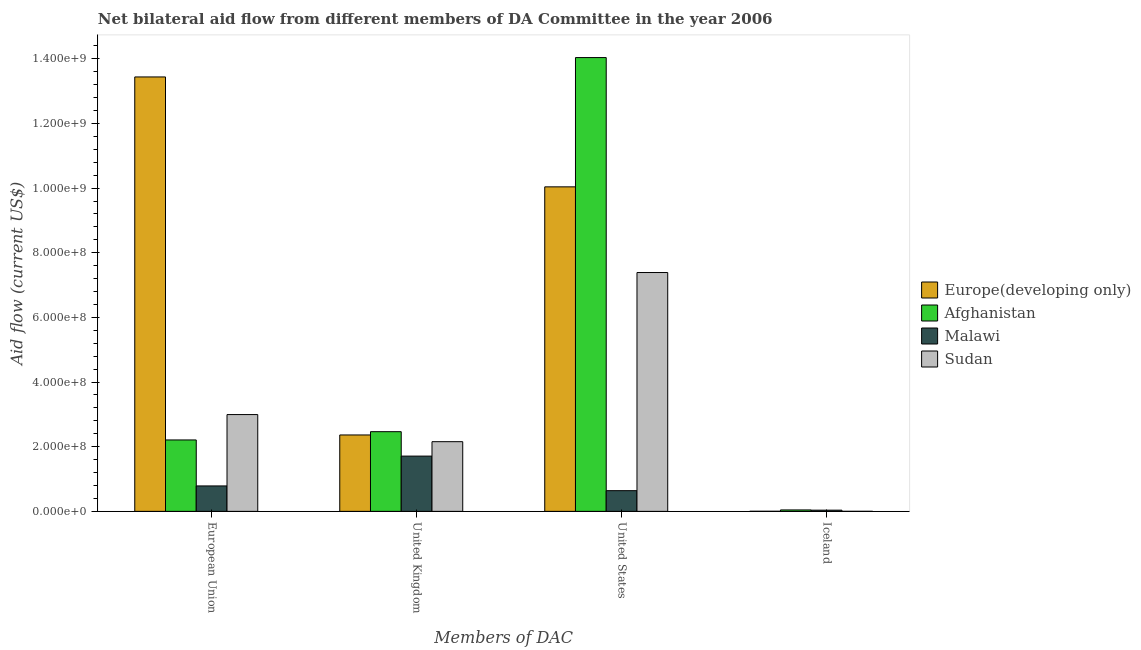Are the number of bars per tick equal to the number of legend labels?
Your response must be concise. Yes. What is the label of the 4th group of bars from the left?
Provide a short and direct response. Iceland. What is the amount of aid given by uk in Afghanistan?
Give a very brief answer. 2.46e+08. Across all countries, what is the maximum amount of aid given by eu?
Ensure brevity in your answer.  1.34e+09. Across all countries, what is the minimum amount of aid given by iceland?
Make the answer very short. 1.40e+05. In which country was the amount of aid given by iceland maximum?
Offer a very short reply. Afghanistan. In which country was the amount of aid given by eu minimum?
Offer a very short reply. Malawi. What is the total amount of aid given by us in the graph?
Keep it short and to the point. 3.21e+09. What is the difference between the amount of aid given by uk in Malawi and that in Afghanistan?
Give a very brief answer. -7.56e+07. What is the difference between the amount of aid given by uk in Afghanistan and the amount of aid given by us in Malawi?
Offer a very short reply. 1.82e+08. What is the average amount of aid given by eu per country?
Make the answer very short. 4.86e+08. What is the difference between the amount of aid given by us and amount of aid given by eu in Sudan?
Offer a very short reply. 4.39e+08. In how many countries, is the amount of aid given by us greater than 1400000000 US$?
Your answer should be compact. 1. What is the ratio of the amount of aid given by eu in Sudan to that in Malawi?
Provide a short and direct response. 3.81. What is the difference between the highest and the second highest amount of aid given by iceland?
Offer a terse response. 6.90e+05. What is the difference between the highest and the lowest amount of aid given by iceland?
Provide a succinct answer. 4.28e+06. In how many countries, is the amount of aid given by uk greater than the average amount of aid given by uk taken over all countries?
Offer a very short reply. 2. What does the 2nd bar from the left in United States represents?
Provide a succinct answer. Afghanistan. What does the 1st bar from the right in United Kingdom represents?
Offer a terse response. Sudan. Is it the case that in every country, the sum of the amount of aid given by eu and amount of aid given by uk is greater than the amount of aid given by us?
Ensure brevity in your answer.  No. How many bars are there?
Keep it short and to the point. 16. Are all the bars in the graph horizontal?
Ensure brevity in your answer.  No. Does the graph contain any zero values?
Your answer should be compact. No. Does the graph contain grids?
Make the answer very short. No. How are the legend labels stacked?
Your answer should be compact. Vertical. What is the title of the graph?
Offer a terse response. Net bilateral aid flow from different members of DA Committee in the year 2006. What is the label or title of the X-axis?
Offer a very short reply. Members of DAC. What is the Aid flow (current US$) in Europe(developing only) in European Union?
Offer a very short reply. 1.34e+09. What is the Aid flow (current US$) of Afghanistan in European Union?
Provide a succinct answer. 2.21e+08. What is the Aid flow (current US$) in Malawi in European Union?
Give a very brief answer. 7.87e+07. What is the Aid flow (current US$) in Sudan in European Union?
Offer a terse response. 2.99e+08. What is the Aid flow (current US$) in Europe(developing only) in United Kingdom?
Provide a short and direct response. 2.36e+08. What is the Aid flow (current US$) of Afghanistan in United Kingdom?
Keep it short and to the point. 2.46e+08. What is the Aid flow (current US$) of Malawi in United Kingdom?
Keep it short and to the point. 1.71e+08. What is the Aid flow (current US$) in Sudan in United Kingdom?
Ensure brevity in your answer.  2.16e+08. What is the Aid flow (current US$) in Europe(developing only) in United States?
Offer a very short reply. 1.00e+09. What is the Aid flow (current US$) in Afghanistan in United States?
Offer a terse response. 1.40e+09. What is the Aid flow (current US$) of Malawi in United States?
Provide a short and direct response. 6.40e+07. What is the Aid flow (current US$) in Sudan in United States?
Provide a short and direct response. 7.39e+08. What is the Aid flow (current US$) in Europe(developing only) in Iceland?
Provide a succinct answer. 2.80e+05. What is the Aid flow (current US$) of Afghanistan in Iceland?
Your response must be concise. 4.42e+06. What is the Aid flow (current US$) in Malawi in Iceland?
Offer a very short reply. 3.73e+06. What is the Aid flow (current US$) of Sudan in Iceland?
Your answer should be compact. 1.40e+05. Across all Members of DAC, what is the maximum Aid flow (current US$) in Europe(developing only)?
Your answer should be compact. 1.34e+09. Across all Members of DAC, what is the maximum Aid flow (current US$) in Afghanistan?
Your answer should be compact. 1.40e+09. Across all Members of DAC, what is the maximum Aid flow (current US$) of Malawi?
Offer a terse response. 1.71e+08. Across all Members of DAC, what is the maximum Aid flow (current US$) in Sudan?
Make the answer very short. 7.39e+08. Across all Members of DAC, what is the minimum Aid flow (current US$) of Afghanistan?
Ensure brevity in your answer.  4.42e+06. Across all Members of DAC, what is the minimum Aid flow (current US$) of Malawi?
Offer a very short reply. 3.73e+06. What is the total Aid flow (current US$) in Europe(developing only) in the graph?
Provide a short and direct response. 2.58e+09. What is the total Aid flow (current US$) in Afghanistan in the graph?
Offer a terse response. 1.88e+09. What is the total Aid flow (current US$) in Malawi in the graph?
Keep it short and to the point. 3.17e+08. What is the total Aid flow (current US$) in Sudan in the graph?
Your response must be concise. 1.25e+09. What is the difference between the Aid flow (current US$) of Europe(developing only) in European Union and that in United Kingdom?
Provide a short and direct response. 1.11e+09. What is the difference between the Aid flow (current US$) in Afghanistan in European Union and that in United Kingdom?
Offer a very short reply. -2.56e+07. What is the difference between the Aid flow (current US$) in Malawi in European Union and that in United Kingdom?
Provide a short and direct response. -9.23e+07. What is the difference between the Aid flow (current US$) in Sudan in European Union and that in United Kingdom?
Offer a terse response. 8.39e+07. What is the difference between the Aid flow (current US$) in Europe(developing only) in European Union and that in United States?
Ensure brevity in your answer.  3.40e+08. What is the difference between the Aid flow (current US$) of Afghanistan in European Union and that in United States?
Your response must be concise. -1.18e+09. What is the difference between the Aid flow (current US$) in Malawi in European Union and that in United States?
Provide a short and direct response. 1.46e+07. What is the difference between the Aid flow (current US$) in Sudan in European Union and that in United States?
Offer a very short reply. -4.39e+08. What is the difference between the Aid flow (current US$) in Europe(developing only) in European Union and that in Iceland?
Provide a short and direct response. 1.34e+09. What is the difference between the Aid flow (current US$) of Afghanistan in European Union and that in Iceland?
Provide a short and direct response. 2.16e+08. What is the difference between the Aid flow (current US$) in Malawi in European Union and that in Iceland?
Keep it short and to the point. 7.49e+07. What is the difference between the Aid flow (current US$) in Sudan in European Union and that in Iceland?
Make the answer very short. 2.99e+08. What is the difference between the Aid flow (current US$) in Europe(developing only) in United Kingdom and that in United States?
Offer a terse response. -7.67e+08. What is the difference between the Aid flow (current US$) of Afghanistan in United Kingdom and that in United States?
Your answer should be very brief. -1.16e+09. What is the difference between the Aid flow (current US$) in Malawi in United Kingdom and that in United States?
Offer a very short reply. 1.07e+08. What is the difference between the Aid flow (current US$) in Sudan in United Kingdom and that in United States?
Offer a very short reply. -5.23e+08. What is the difference between the Aid flow (current US$) in Europe(developing only) in United Kingdom and that in Iceland?
Make the answer very short. 2.36e+08. What is the difference between the Aid flow (current US$) in Afghanistan in United Kingdom and that in Iceland?
Make the answer very short. 2.42e+08. What is the difference between the Aid flow (current US$) of Malawi in United Kingdom and that in Iceland?
Your response must be concise. 1.67e+08. What is the difference between the Aid flow (current US$) of Sudan in United Kingdom and that in Iceland?
Your answer should be very brief. 2.15e+08. What is the difference between the Aid flow (current US$) in Europe(developing only) in United States and that in Iceland?
Give a very brief answer. 1.00e+09. What is the difference between the Aid flow (current US$) of Afghanistan in United States and that in Iceland?
Offer a terse response. 1.40e+09. What is the difference between the Aid flow (current US$) of Malawi in United States and that in Iceland?
Offer a terse response. 6.03e+07. What is the difference between the Aid flow (current US$) of Sudan in United States and that in Iceland?
Give a very brief answer. 7.39e+08. What is the difference between the Aid flow (current US$) in Europe(developing only) in European Union and the Aid flow (current US$) in Afghanistan in United Kingdom?
Your answer should be compact. 1.10e+09. What is the difference between the Aid flow (current US$) of Europe(developing only) in European Union and the Aid flow (current US$) of Malawi in United Kingdom?
Your response must be concise. 1.17e+09. What is the difference between the Aid flow (current US$) in Europe(developing only) in European Union and the Aid flow (current US$) in Sudan in United Kingdom?
Ensure brevity in your answer.  1.13e+09. What is the difference between the Aid flow (current US$) in Afghanistan in European Union and the Aid flow (current US$) in Malawi in United Kingdom?
Offer a very short reply. 5.00e+07. What is the difference between the Aid flow (current US$) in Afghanistan in European Union and the Aid flow (current US$) in Sudan in United Kingdom?
Keep it short and to the point. 5.35e+06. What is the difference between the Aid flow (current US$) in Malawi in European Union and the Aid flow (current US$) in Sudan in United Kingdom?
Provide a short and direct response. -1.37e+08. What is the difference between the Aid flow (current US$) of Europe(developing only) in European Union and the Aid flow (current US$) of Afghanistan in United States?
Keep it short and to the point. -5.99e+07. What is the difference between the Aid flow (current US$) in Europe(developing only) in European Union and the Aid flow (current US$) in Malawi in United States?
Your answer should be compact. 1.28e+09. What is the difference between the Aid flow (current US$) in Europe(developing only) in European Union and the Aid flow (current US$) in Sudan in United States?
Your response must be concise. 6.05e+08. What is the difference between the Aid flow (current US$) of Afghanistan in European Union and the Aid flow (current US$) of Malawi in United States?
Provide a succinct answer. 1.57e+08. What is the difference between the Aid flow (current US$) in Afghanistan in European Union and the Aid flow (current US$) in Sudan in United States?
Offer a very short reply. -5.18e+08. What is the difference between the Aid flow (current US$) in Malawi in European Union and the Aid flow (current US$) in Sudan in United States?
Your answer should be compact. -6.60e+08. What is the difference between the Aid flow (current US$) of Europe(developing only) in European Union and the Aid flow (current US$) of Afghanistan in Iceland?
Keep it short and to the point. 1.34e+09. What is the difference between the Aid flow (current US$) in Europe(developing only) in European Union and the Aid flow (current US$) in Malawi in Iceland?
Ensure brevity in your answer.  1.34e+09. What is the difference between the Aid flow (current US$) of Europe(developing only) in European Union and the Aid flow (current US$) of Sudan in Iceland?
Offer a terse response. 1.34e+09. What is the difference between the Aid flow (current US$) in Afghanistan in European Union and the Aid flow (current US$) in Malawi in Iceland?
Provide a succinct answer. 2.17e+08. What is the difference between the Aid flow (current US$) in Afghanistan in European Union and the Aid flow (current US$) in Sudan in Iceland?
Your answer should be very brief. 2.21e+08. What is the difference between the Aid flow (current US$) of Malawi in European Union and the Aid flow (current US$) of Sudan in Iceland?
Your answer should be very brief. 7.85e+07. What is the difference between the Aid flow (current US$) of Europe(developing only) in United Kingdom and the Aid flow (current US$) of Afghanistan in United States?
Make the answer very short. -1.17e+09. What is the difference between the Aid flow (current US$) in Europe(developing only) in United Kingdom and the Aid flow (current US$) in Malawi in United States?
Make the answer very short. 1.72e+08. What is the difference between the Aid flow (current US$) in Europe(developing only) in United Kingdom and the Aid flow (current US$) in Sudan in United States?
Make the answer very short. -5.02e+08. What is the difference between the Aid flow (current US$) in Afghanistan in United Kingdom and the Aid flow (current US$) in Malawi in United States?
Offer a terse response. 1.82e+08. What is the difference between the Aid flow (current US$) of Afghanistan in United Kingdom and the Aid flow (current US$) of Sudan in United States?
Offer a terse response. -4.92e+08. What is the difference between the Aid flow (current US$) of Malawi in United Kingdom and the Aid flow (current US$) of Sudan in United States?
Your response must be concise. -5.68e+08. What is the difference between the Aid flow (current US$) in Europe(developing only) in United Kingdom and the Aid flow (current US$) in Afghanistan in Iceland?
Your answer should be compact. 2.32e+08. What is the difference between the Aid flow (current US$) of Europe(developing only) in United Kingdom and the Aid flow (current US$) of Malawi in Iceland?
Offer a terse response. 2.33e+08. What is the difference between the Aid flow (current US$) of Europe(developing only) in United Kingdom and the Aid flow (current US$) of Sudan in Iceland?
Provide a succinct answer. 2.36e+08. What is the difference between the Aid flow (current US$) of Afghanistan in United Kingdom and the Aid flow (current US$) of Malawi in Iceland?
Give a very brief answer. 2.43e+08. What is the difference between the Aid flow (current US$) of Afghanistan in United Kingdom and the Aid flow (current US$) of Sudan in Iceland?
Provide a succinct answer. 2.46e+08. What is the difference between the Aid flow (current US$) of Malawi in United Kingdom and the Aid flow (current US$) of Sudan in Iceland?
Provide a short and direct response. 1.71e+08. What is the difference between the Aid flow (current US$) in Europe(developing only) in United States and the Aid flow (current US$) in Afghanistan in Iceland?
Your response must be concise. 9.99e+08. What is the difference between the Aid flow (current US$) in Europe(developing only) in United States and the Aid flow (current US$) in Malawi in Iceland?
Keep it short and to the point. 1.00e+09. What is the difference between the Aid flow (current US$) of Europe(developing only) in United States and the Aid flow (current US$) of Sudan in Iceland?
Offer a terse response. 1.00e+09. What is the difference between the Aid flow (current US$) in Afghanistan in United States and the Aid flow (current US$) in Malawi in Iceland?
Give a very brief answer. 1.40e+09. What is the difference between the Aid flow (current US$) of Afghanistan in United States and the Aid flow (current US$) of Sudan in Iceland?
Give a very brief answer. 1.40e+09. What is the difference between the Aid flow (current US$) in Malawi in United States and the Aid flow (current US$) in Sudan in Iceland?
Give a very brief answer. 6.39e+07. What is the average Aid flow (current US$) of Europe(developing only) per Members of DAC?
Provide a short and direct response. 6.46e+08. What is the average Aid flow (current US$) in Afghanistan per Members of DAC?
Offer a very short reply. 4.69e+08. What is the average Aid flow (current US$) of Malawi per Members of DAC?
Provide a succinct answer. 7.93e+07. What is the average Aid flow (current US$) in Sudan per Members of DAC?
Offer a very short reply. 3.13e+08. What is the difference between the Aid flow (current US$) in Europe(developing only) and Aid flow (current US$) in Afghanistan in European Union?
Provide a short and direct response. 1.12e+09. What is the difference between the Aid flow (current US$) in Europe(developing only) and Aid flow (current US$) in Malawi in European Union?
Make the answer very short. 1.27e+09. What is the difference between the Aid flow (current US$) in Europe(developing only) and Aid flow (current US$) in Sudan in European Union?
Your response must be concise. 1.04e+09. What is the difference between the Aid flow (current US$) of Afghanistan and Aid flow (current US$) of Malawi in European Union?
Your response must be concise. 1.42e+08. What is the difference between the Aid flow (current US$) of Afghanistan and Aid flow (current US$) of Sudan in European Union?
Your answer should be compact. -7.85e+07. What is the difference between the Aid flow (current US$) in Malawi and Aid flow (current US$) in Sudan in European Union?
Offer a terse response. -2.21e+08. What is the difference between the Aid flow (current US$) in Europe(developing only) and Aid flow (current US$) in Afghanistan in United Kingdom?
Your answer should be very brief. -1.02e+07. What is the difference between the Aid flow (current US$) in Europe(developing only) and Aid flow (current US$) in Malawi in United Kingdom?
Your response must be concise. 6.54e+07. What is the difference between the Aid flow (current US$) of Europe(developing only) and Aid flow (current US$) of Sudan in United Kingdom?
Provide a succinct answer. 2.08e+07. What is the difference between the Aid flow (current US$) of Afghanistan and Aid flow (current US$) of Malawi in United Kingdom?
Provide a short and direct response. 7.56e+07. What is the difference between the Aid flow (current US$) in Afghanistan and Aid flow (current US$) in Sudan in United Kingdom?
Offer a very short reply. 3.09e+07. What is the difference between the Aid flow (current US$) of Malawi and Aid flow (current US$) of Sudan in United Kingdom?
Your response must be concise. -4.46e+07. What is the difference between the Aid flow (current US$) in Europe(developing only) and Aid flow (current US$) in Afghanistan in United States?
Ensure brevity in your answer.  -4.00e+08. What is the difference between the Aid flow (current US$) of Europe(developing only) and Aid flow (current US$) of Malawi in United States?
Keep it short and to the point. 9.40e+08. What is the difference between the Aid flow (current US$) in Europe(developing only) and Aid flow (current US$) in Sudan in United States?
Offer a very short reply. 2.65e+08. What is the difference between the Aid flow (current US$) in Afghanistan and Aid flow (current US$) in Malawi in United States?
Offer a very short reply. 1.34e+09. What is the difference between the Aid flow (current US$) in Afghanistan and Aid flow (current US$) in Sudan in United States?
Your response must be concise. 6.65e+08. What is the difference between the Aid flow (current US$) of Malawi and Aid flow (current US$) of Sudan in United States?
Your answer should be compact. -6.75e+08. What is the difference between the Aid flow (current US$) of Europe(developing only) and Aid flow (current US$) of Afghanistan in Iceland?
Your answer should be compact. -4.14e+06. What is the difference between the Aid flow (current US$) of Europe(developing only) and Aid flow (current US$) of Malawi in Iceland?
Your answer should be compact. -3.45e+06. What is the difference between the Aid flow (current US$) of Europe(developing only) and Aid flow (current US$) of Sudan in Iceland?
Your response must be concise. 1.40e+05. What is the difference between the Aid flow (current US$) of Afghanistan and Aid flow (current US$) of Malawi in Iceland?
Your answer should be compact. 6.90e+05. What is the difference between the Aid flow (current US$) in Afghanistan and Aid flow (current US$) in Sudan in Iceland?
Ensure brevity in your answer.  4.28e+06. What is the difference between the Aid flow (current US$) of Malawi and Aid flow (current US$) of Sudan in Iceland?
Provide a succinct answer. 3.59e+06. What is the ratio of the Aid flow (current US$) of Europe(developing only) in European Union to that in United Kingdom?
Your answer should be compact. 5.69. What is the ratio of the Aid flow (current US$) of Afghanistan in European Union to that in United Kingdom?
Keep it short and to the point. 0.9. What is the ratio of the Aid flow (current US$) of Malawi in European Union to that in United Kingdom?
Give a very brief answer. 0.46. What is the ratio of the Aid flow (current US$) of Sudan in European Union to that in United Kingdom?
Offer a terse response. 1.39. What is the ratio of the Aid flow (current US$) of Europe(developing only) in European Union to that in United States?
Make the answer very short. 1.34. What is the ratio of the Aid flow (current US$) in Afghanistan in European Union to that in United States?
Your answer should be very brief. 0.16. What is the ratio of the Aid flow (current US$) in Malawi in European Union to that in United States?
Offer a very short reply. 1.23. What is the ratio of the Aid flow (current US$) in Sudan in European Union to that in United States?
Provide a short and direct response. 0.41. What is the ratio of the Aid flow (current US$) in Europe(developing only) in European Union to that in Iceland?
Provide a short and direct response. 4799.21. What is the ratio of the Aid flow (current US$) of Afghanistan in European Union to that in Iceland?
Your answer should be very brief. 49.98. What is the ratio of the Aid flow (current US$) in Malawi in European Union to that in Iceland?
Provide a succinct answer. 21.09. What is the ratio of the Aid flow (current US$) of Sudan in European Union to that in Iceland?
Your response must be concise. 2138.64. What is the ratio of the Aid flow (current US$) in Europe(developing only) in United Kingdom to that in United States?
Provide a succinct answer. 0.24. What is the ratio of the Aid flow (current US$) in Afghanistan in United Kingdom to that in United States?
Your answer should be very brief. 0.18. What is the ratio of the Aid flow (current US$) of Malawi in United Kingdom to that in United States?
Ensure brevity in your answer.  2.67. What is the ratio of the Aid flow (current US$) in Sudan in United Kingdom to that in United States?
Provide a short and direct response. 0.29. What is the ratio of the Aid flow (current US$) of Europe(developing only) in United Kingdom to that in Iceland?
Offer a terse response. 844. What is the ratio of the Aid flow (current US$) of Afghanistan in United Kingdom to that in Iceland?
Offer a very short reply. 55.77. What is the ratio of the Aid flow (current US$) in Malawi in United Kingdom to that in Iceland?
Keep it short and to the point. 45.83. What is the ratio of the Aid flow (current US$) in Sudan in United Kingdom to that in Iceland?
Offer a terse response. 1539.64. What is the ratio of the Aid flow (current US$) in Europe(developing only) in United States to that in Iceland?
Make the answer very short. 3585.04. What is the ratio of the Aid flow (current US$) in Afghanistan in United States to that in Iceland?
Your answer should be compact. 317.58. What is the ratio of the Aid flow (current US$) in Malawi in United States to that in Iceland?
Provide a succinct answer. 17.16. What is the ratio of the Aid flow (current US$) of Sudan in United States to that in Iceland?
Make the answer very short. 5277. What is the difference between the highest and the second highest Aid flow (current US$) in Europe(developing only)?
Your response must be concise. 3.40e+08. What is the difference between the highest and the second highest Aid flow (current US$) of Afghanistan?
Your response must be concise. 1.16e+09. What is the difference between the highest and the second highest Aid flow (current US$) of Malawi?
Make the answer very short. 9.23e+07. What is the difference between the highest and the second highest Aid flow (current US$) of Sudan?
Provide a short and direct response. 4.39e+08. What is the difference between the highest and the lowest Aid flow (current US$) in Europe(developing only)?
Keep it short and to the point. 1.34e+09. What is the difference between the highest and the lowest Aid flow (current US$) in Afghanistan?
Your answer should be compact. 1.40e+09. What is the difference between the highest and the lowest Aid flow (current US$) of Malawi?
Offer a terse response. 1.67e+08. What is the difference between the highest and the lowest Aid flow (current US$) in Sudan?
Make the answer very short. 7.39e+08. 